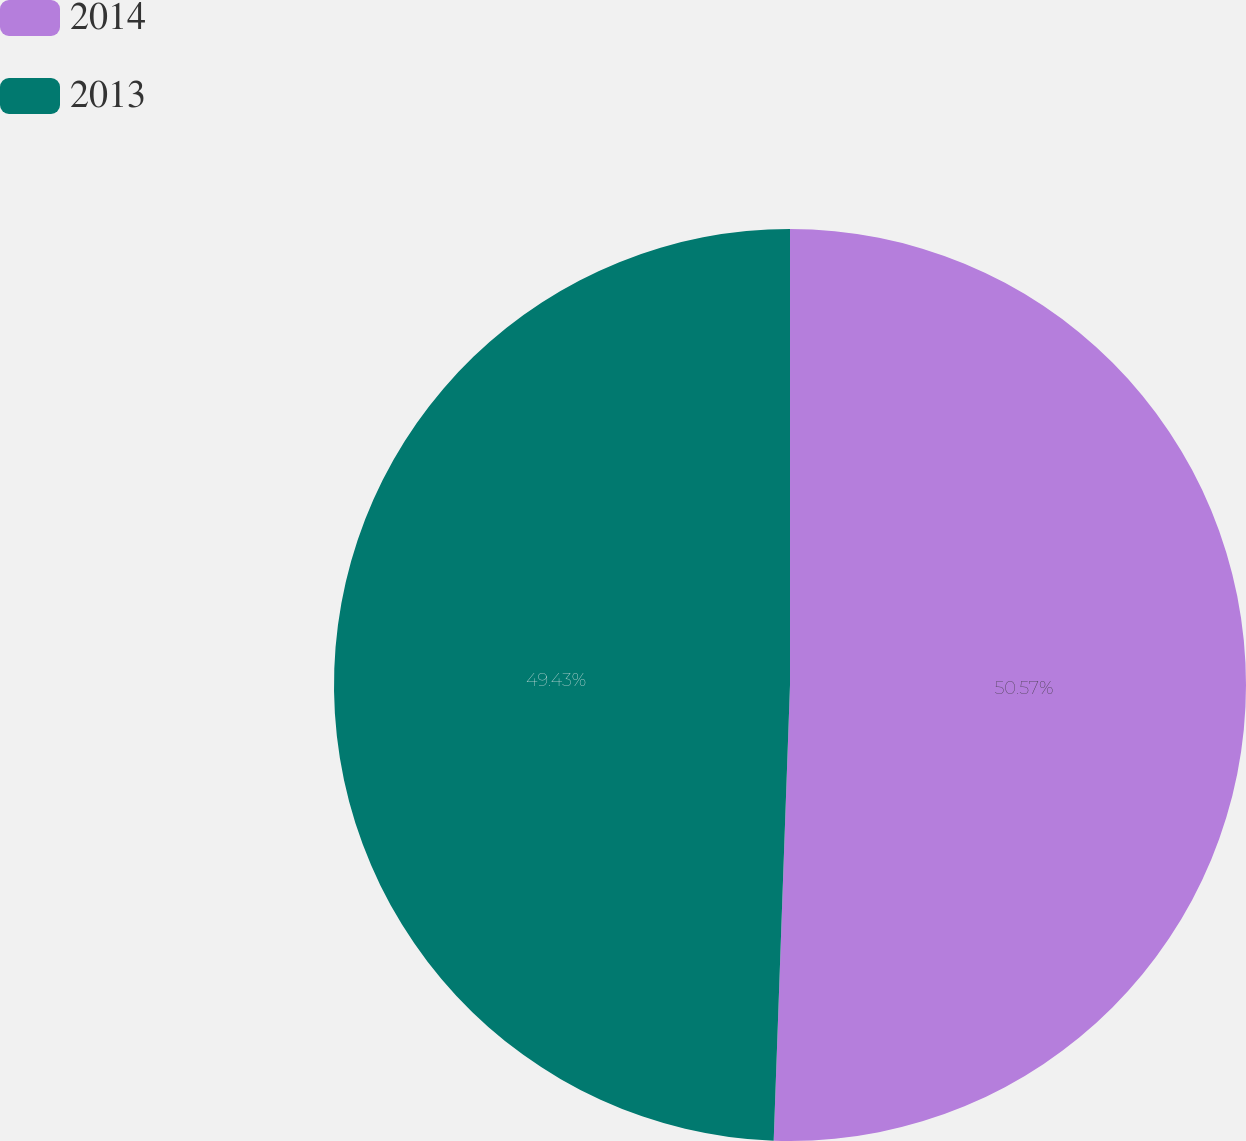Convert chart to OTSL. <chart><loc_0><loc_0><loc_500><loc_500><pie_chart><fcel>2014<fcel>2013<nl><fcel>50.57%<fcel>49.43%<nl></chart> 